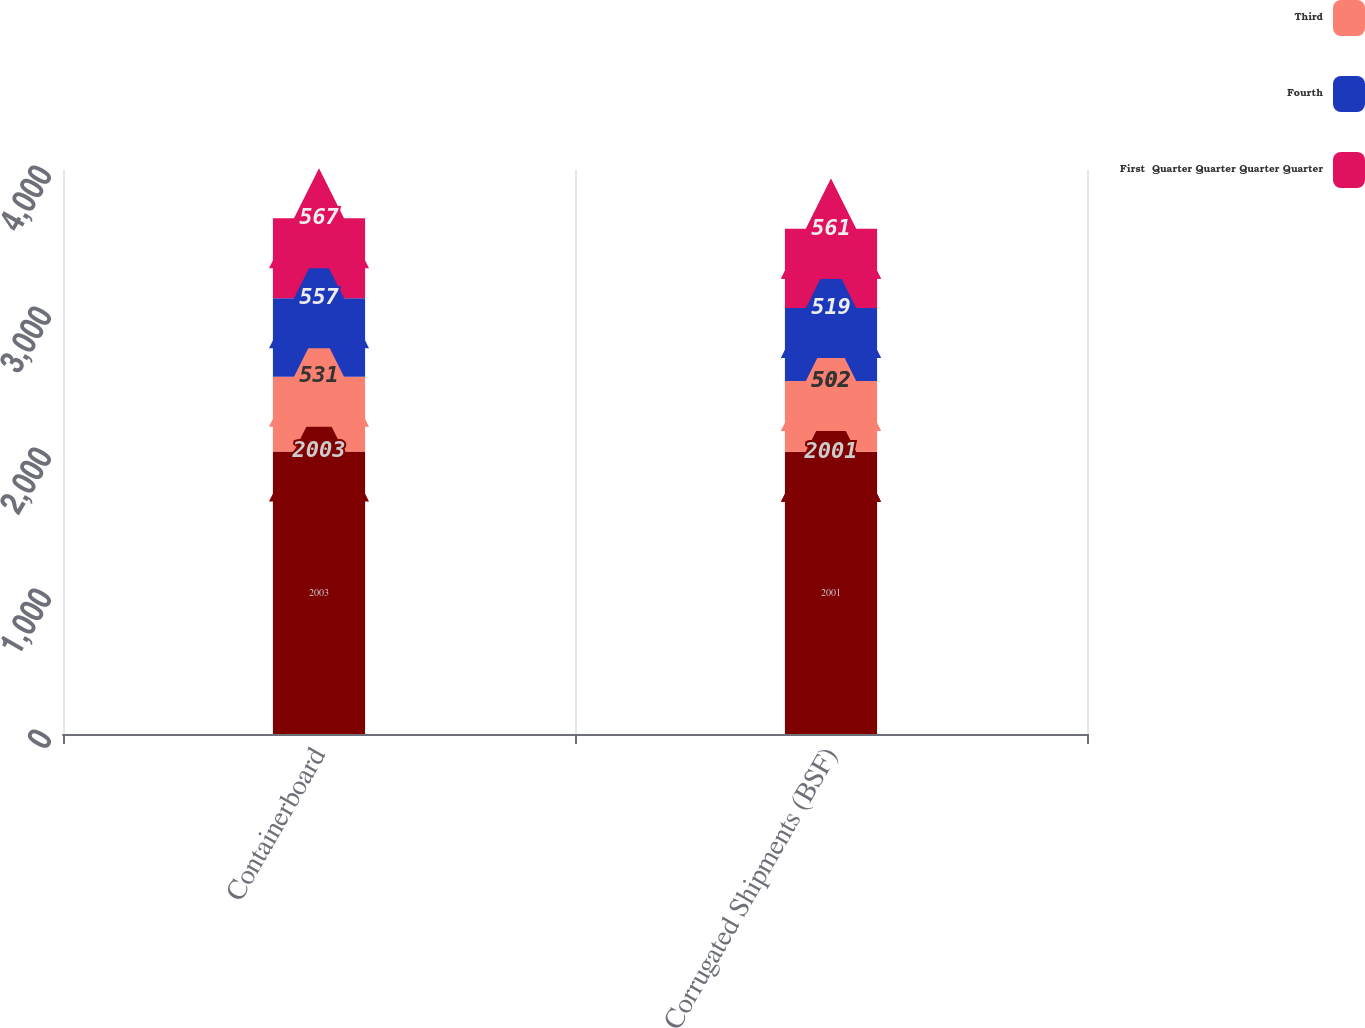Convert chart to OTSL. <chart><loc_0><loc_0><loc_500><loc_500><stacked_bar_chart><ecel><fcel>Containerboard<fcel>Corrugated Shipments (BSF)<nl><fcel>nan<fcel>2003<fcel>2001<nl><fcel>Third<fcel>531<fcel>502<nl><fcel>Fourth<fcel>557<fcel>519<nl><fcel>First  Quarter Quarter Quarter Quarter<fcel>567<fcel>561<nl></chart> 